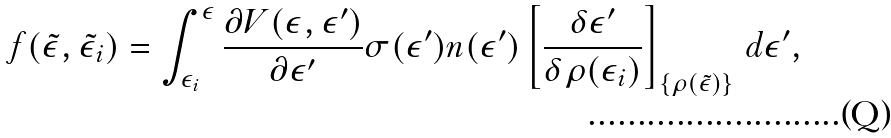Convert formula to latex. <formula><loc_0><loc_0><loc_500><loc_500>f ( \tilde { \epsilon } , \tilde { \epsilon } _ { i } ) = \int _ { \epsilon _ { i } } ^ { \epsilon } \frac { \partial V ( \epsilon , \epsilon ^ { \prime } ) } { \partial \epsilon ^ { \prime } } \sigma ( \epsilon ^ { \prime } ) n ( \epsilon ^ { \prime } ) \left [ \frac { \delta \epsilon ^ { \prime } } { \delta \rho ( \epsilon _ { i } ) } \right ] _ { \{ \rho ( \tilde { \epsilon } ) \} } \, d \epsilon ^ { \prime } ,</formula> 